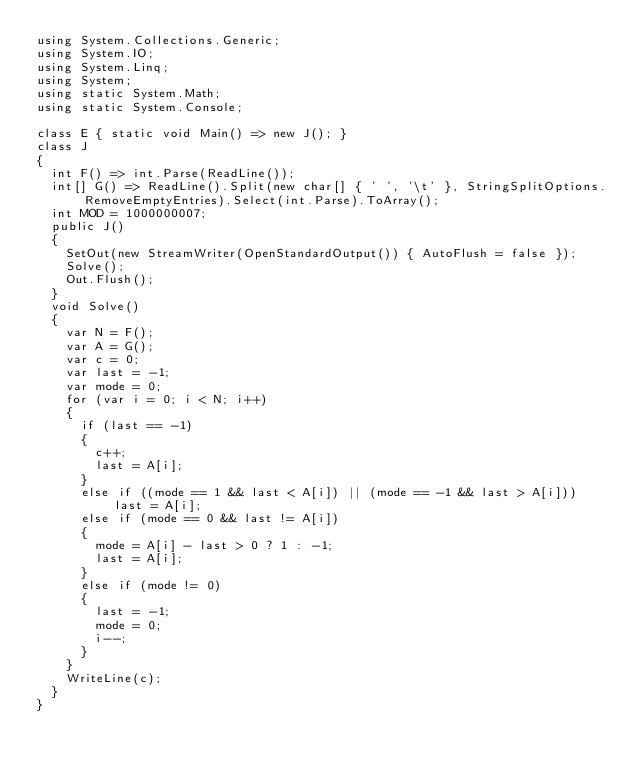<code> <loc_0><loc_0><loc_500><loc_500><_C#_>using System.Collections.Generic;
using System.IO;
using System.Linq;
using System;
using static System.Math;
using static System.Console;

class E { static void Main() => new J(); }
class J
{
	int F() => int.Parse(ReadLine());
	int[] G() => ReadLine().Split(new char[] { ' ', '\t' }, StringSplitOptions.RemoveEmptyEntries).Select(int.Parse).ToArray();
	int MOD = 1000000007;
	public J()
	{
		SetOut(new StreamWriter(OpenStandardOutput()) { AutoFlush = false });
		Solve();
		Out.Flush();
	}
	void Solve()
	{
		var N = F();
		var A = G();
		var c = 0;
		var last = -1;
		var mode = 0;
		for (var i = 0; i < N; i++)
		{
			if (last == -1)
			{
				c++;
				last = A[i];
			}
			else if ((mode == 1 && last < A[i]) || (mode == -1 && last > A[i])) last = A[i];
			else if (mode == 0 && last != A[i])
			{
				mode = A[i] - last > 0 ? 1 : -1;
				last = A[i];
			}
			else if (mode != 0)
			{
				last = -1;
				mode = 0;
				i--;
			}
		}
		WriteLine(c);
	}
}</code> 